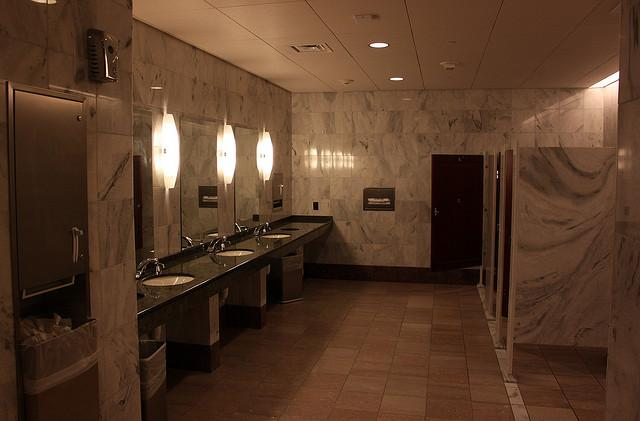What material is the tile for the walls and stalls of this bathroom?

Choices:
A) porcelain
B) plastic
C) marble
D) laminate marble 